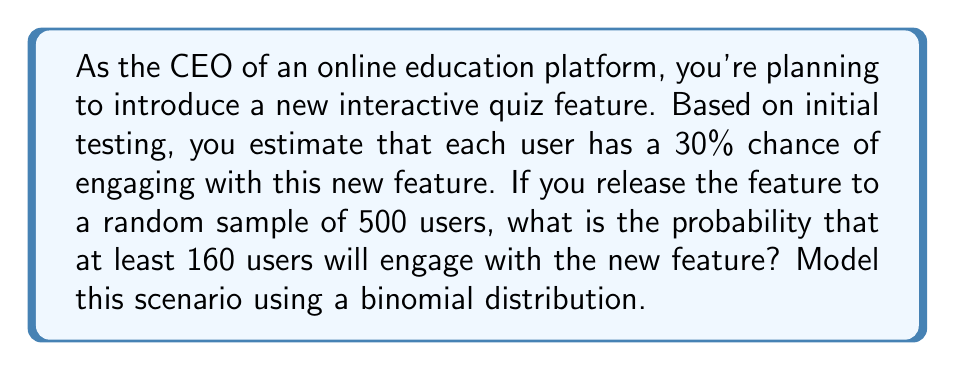Help me with this question. Let's approach this step-by-step:

1) First, we identify the parameters of our binomial distribution:
   - $n = 500$ (number of users)
   - $p = 0.30$ (probability of success, i.e., engaging with the feature)
   - We want $P(X \geq 160)$, where $X$ is the number of users engaging with the feature

2) In a binomial distribution, $X \sim B(n,p)$, the probability of exactly $k$ successes is given by:

   $$P(X = k) = \binom{n}{k} p^k (1-p)^{n-k}$$

3) We want $P(X \geq 160)$, which is equivalent to $1 - P(X < 160)$ or $1 - P(X \leq 159)$

4) Calculating $P(X \leq 159)$ directly would involve summing 160 terms, which is computationally intensive. Instead, we can use the normal approximation to the binomial distribution.

5) For large $n$ and $np > 5$, $n(1-p) > 5$ (both conditions are met here), we can approximate the binomial distribution with a normal distribution:

   $X \sim N(\mu, \sigma^2)$ where $\mu = np$ and $\sigma^2 = np(1-p)$

6) In our case:
   $\mu = 500 * 0.30 = 150$
   $\sigma^2 = 500 * 0.30 * 0.70 = 105$
   $\sigma = \sqrt{105} \approx 10.25$

7) We need to apply a continuity correction. Instead of $P(X < 160)$, we calculate $P(X < 159.5)$

8) We standardize our normal distribution:
   $z = \frac{159.5 - 150}{10.25} \approx 0.93$

9) Using a standard normal table or calculator, we find:
   $P(Z < 0.93) \approx 0.8238$

10) Therefore, $P(X \geq 160) = 1 - P(X < 160) \approx 1 - 0.8238 = 0.1762$
Answer: 0.1762 or 17.62% 